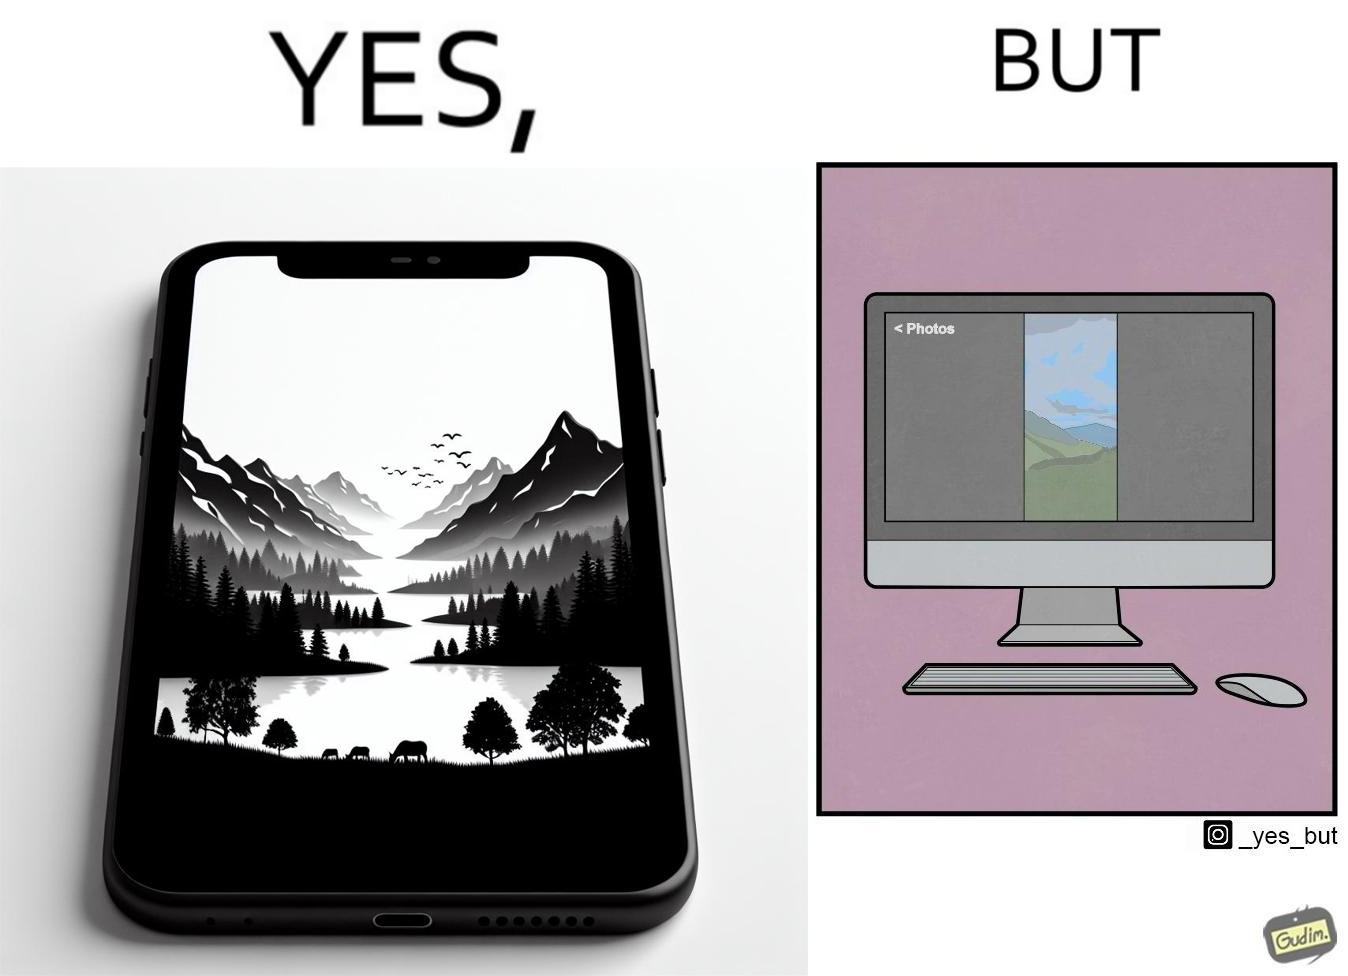Describe what you see in this image. This image is funny, as when using the "photos" app on mobile, it shows you images perfectly, which fill the entire screen, but when viewing the same photos on the computer monitor, the same images have a very limited coverage of the screen. 